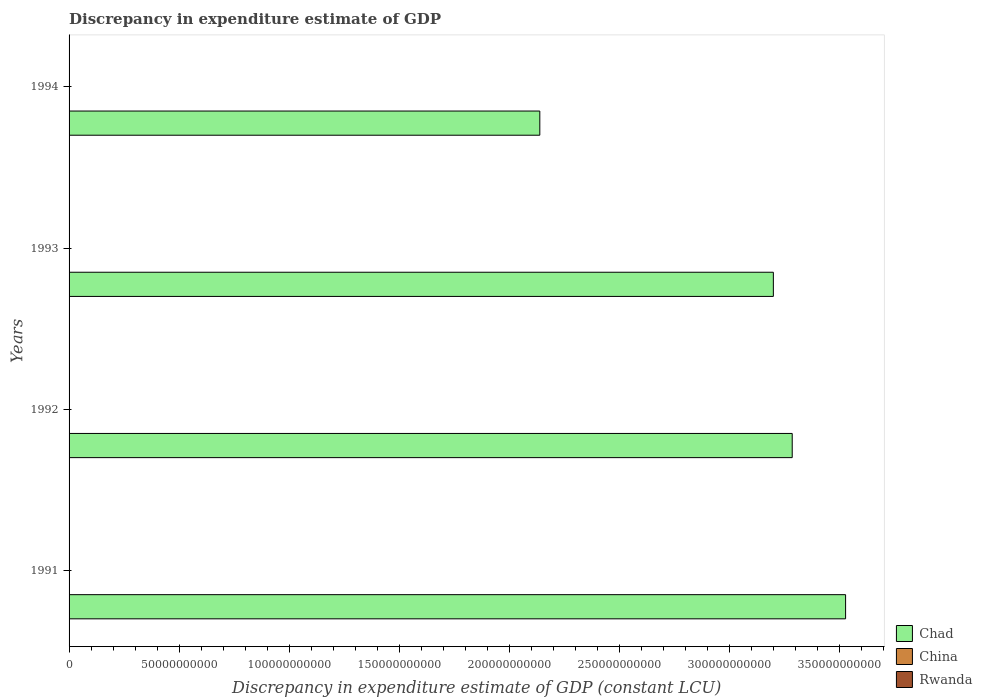Are the number of bars per tick equal to the number of legend labels?
Ensure brevity in your answer.  No. Are the number of bars on each tick of the Y-axis equal?
Keep it short and to the point. Yes. In how many cases, is the number of bars for a given year not equal to the number of legend labels?
Your response must be concise. 4. What is the discrepancy in expenditure estimate of GDP in Rwanda in 1992?
Your response must be concise. 0. Across all years, what is the maximum discrepancy in expenditure estimate of GDP in Chad?
Offer a terse response. 3.53e+11. Across all years, what is the minimum discrepancy in expenditure estimate of GDP in Chad?
Your answer should be compact. 2.14e+11. What is the total discrepancy in expenditure estimate of GDP in Chad in the graph?
Your answer should be very brief. 1.21e+12. What is the difference between the discrepancy in expenditure estimate of GDP in Chad in 1993 and that in 1994?
Your answer should be very brief. 1.06e+11. What is the difference between the discrepancy in expenditure estimate of GDP in Rwanda in 1994 and the discrepancy in expenditure estimate of GDP in China in 1993?
Give a very brief answer. 0. What is the average discrepancy in expenditure estimate of GDP in Rwanda per year?
Make the answer very short. 0. What is the ratio of the discrepancy in expenditure estimate of GDP in Chad in 1992 to that in 1994?
Provide a succinct answer. 1.54. What is the difference between the highest and the second highest discrepancy in expenditure estimate of GDP in Chad?
Provide a short and direct response. 2.42e+1. What is the difference between the highest and the lowest discrepancy in expenditure estimate of GDP in Chad?
Provide a succinct answer. 1.39e+11. In how many years, is the discrepancy in expenditure estimate of GDP in Rwanda greater than the average discrepancy in expenditure estimate of GDP in Rwanda taken over all years?
Offer a terse response. 0. Is it the case that in every year, the sum of the discrepancy in expenditure estimate of GDP in Rwanda and discrepancy in expenditure estimate of GDP in China is greater than the discrepancy in expenditure estimate of GDP in Chad?
Your response must be concise. No. Are all the bars in the graph horizontal?
Your response must be concise. Yes. Does the graph contain grids?
Offer a terse response. No. What is the title of the graph?
Provide a succinct answer. Discrepancy in expenditure estimate of GDP. What is the label or title of the X-axis?
Keep it short and to the point. Discrepancy in expenditure estimate of GDP (constant LCU). What is the Discrepancy in expenditure estimate of GDP (constant LCU) in Chad in 1991?
Make the answer very short. 3.53e+11. What is the Discrepancy in expenditure estimate of GDP (constant LCU) in China in 1991?
Offer a terse response. 0. What is the Discrepancy in expenditure estimate of GDP (constant LCU) in Chad in 1992?
Offer a very short reply. 3.28e+11. What is the Discrepancy in expenditure estimate of GDP (constant LCU) in Chad in 1993?
Make the answer very short. 3.20e+11. What is the Discrepancy in expenditure estimate of GDP (constant LCU) in Chad in 1994?
Keep it short and to the point. 2.14e+11. Across all years, what is the maximum Discrepancy in expenditure estimate of GDP (constant LCU) of Chad?
Make the answer very short. 3.53e+11. Across all years, what is the minimum Discrepancy in expenditure estimate of GDP (constant LCU) of Chad?
Provide a succinct answer. 2.14e+11. What is the total Discrepancy in expenditure estimate of GDP (constant LCU) in Chad in the graph?
Offer a terse response. 1.21e+12. What is the total Discrepancy in expenditure estimate of GDP (constant LCU) in China in the graph?
Provide a short and direct response. 0. What is the difference between the Discrepancy in expenditure estimate of GDP (constant LCU) of Chad in 1991 and that in 1992?
Offer a very short reply. 2.42e+1. What is the difference between the Discrepancy in expenditure estimate of GDP (constant LCU) of Chad in 1991 and that in 1993?
Offer a terse response. 3.28e+1. What is the difference between the Discrepancy in expenditure estimate of GDP (constant LCU) in Chad in 1991 and that in 1994?
Your response must be concise. 1.39e+11. What is the difference between the Discrepancy in expenditure estimate of GDP (constant LCU) of Chad in 1992 and that in 1993?
Ensure brevity in your answer.  8.57e+09. What is the difference between the Discrepancy in expenditure estimate of GDP (constant LCU) in Chad in 1992 and that in 1994?
Provide a succinct answer. 1.15e+11. What is the difference between the Discrepancy in expenditure estimate of GDP (constant LCU) in Chad in 1993 and that in 1994?
Make the answer very short. 1.06e+11. What is the average Discrepancy in expenditure estimate of GDP (constant LCU) of Chad per year?
Your answer should be very brief. 3.04e+11. What is the average Discrepancy in expenditure estimate of GDP (constant LCU) in Rwanda per year?
Give a very brief answer. 0. What is the ratio of the Discrepancy in expenditure estimate of GDP (constant LCU) of Chad in 1991 to that in 1992?
Your answer should be compact. 1.07. What is the ratio of the Discrepancy in expenditure estimate of GDP (constant LCU) of Chad in 1991 to that in 1993?
Ensure brevity in your answer.  1.1. What is the ratio of the Discrepancy in expenditure estimate of GDP (constant LCU) of Chad in 1991 to that in 1994?
Offer a terse response. 1.65. What is the ratio of the Discrepancy in expenditure estimate of GDP (constant LCU) in Chad in 1992 to that in 1993?
Give a very brief answer. 1.03. What is the ratio of the Discrepancy in expenditure estimate of GDP (constant LCU) in Chad in 1992 to that in 1994?
Your answer should be very brief. 1.54. What is the ratio of the Discrepancy in expenditure estimate of GDP (constant LCU) of Chad in 1993 to that in 1994?
Make the answer very short. 1.5. What is the difference between the highest and the second highest Discrepancy in expenditure estimate of GDP (constant LCU) in Chad?
Ensure brevity in your answer.  2.42e+1. What is the difference between the highest and the lowest Discrepancy in expenditure estimate of GDP (constant LCU) of Chad?
Keep it short and to the point. 1.39e+11. 